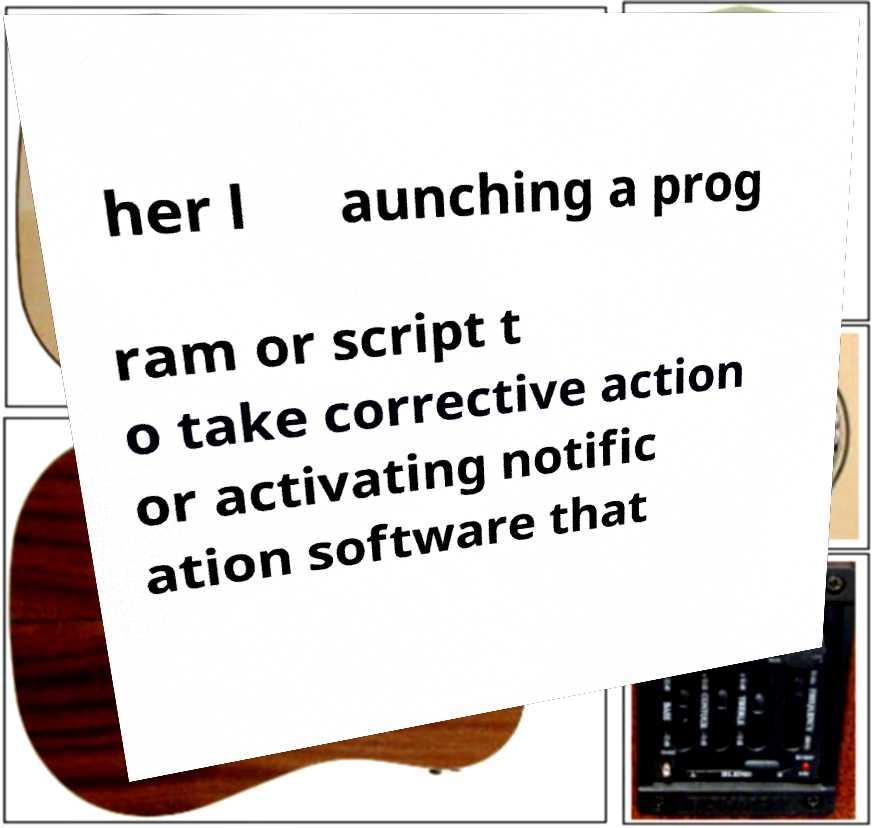What messages or text are displayed in this image? I need them in a readable, typed format. her l aunching a prog ram or script t o take corrective action or activating notific ation software that 